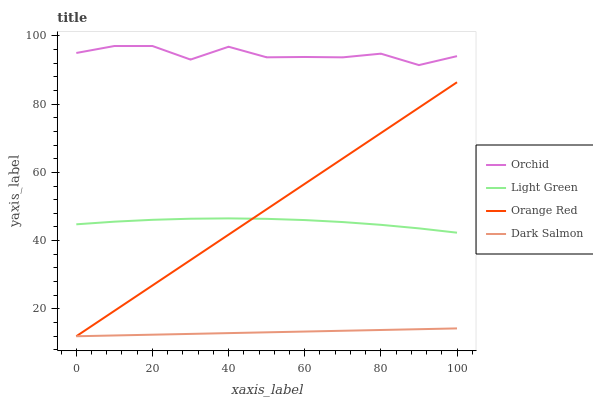Does Orange Red have the minimum area under the curve?
Answer yes or no. No. Does Orange Red have the maximum area under the curve?
Answer yes or no. No. Is Orange Red the smoothest?
Answer yes or no. No. Is Orange Red the roughest?
Answer yes or no. No. Does Light Green have the lowest value?
Answer yes or no. No. Does Orange Red have the highest value?
Answer yes or no. No. Is Dark Salmon less than Light Green?
Answer yes or no. Yes. Is Light Green greater than Dark Salmon?
Answer yes or no. Yes. Does Dark Salmon intersect Light Green?
Answer yes or no. No. 